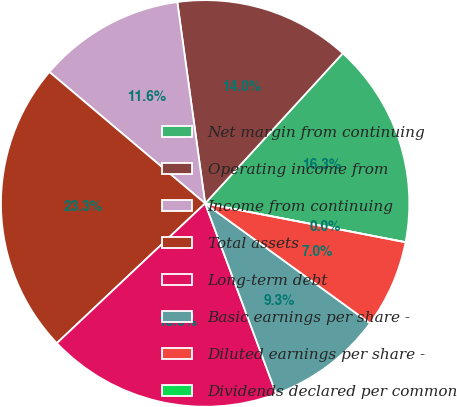<chart> <loc_0><loc_0><loc_500><loc_500><pie_chart><fcel>Net margin from continuing<fcel>Operating income from<fcel>Income from continuing<fcel>Total assets<fcel>Long-term debt<fcel>Basic earnings per share -<fcel>Diluted earnings per share -<fcel>Dividends declared per common<nl><fcel>16.28%<fcel>13.95%<fcel>11.63%<fcel>23.25%<fcel>18.6%<fcel>9.3%<fcel>6.98%<fcel>0.0%<nl></chart> 